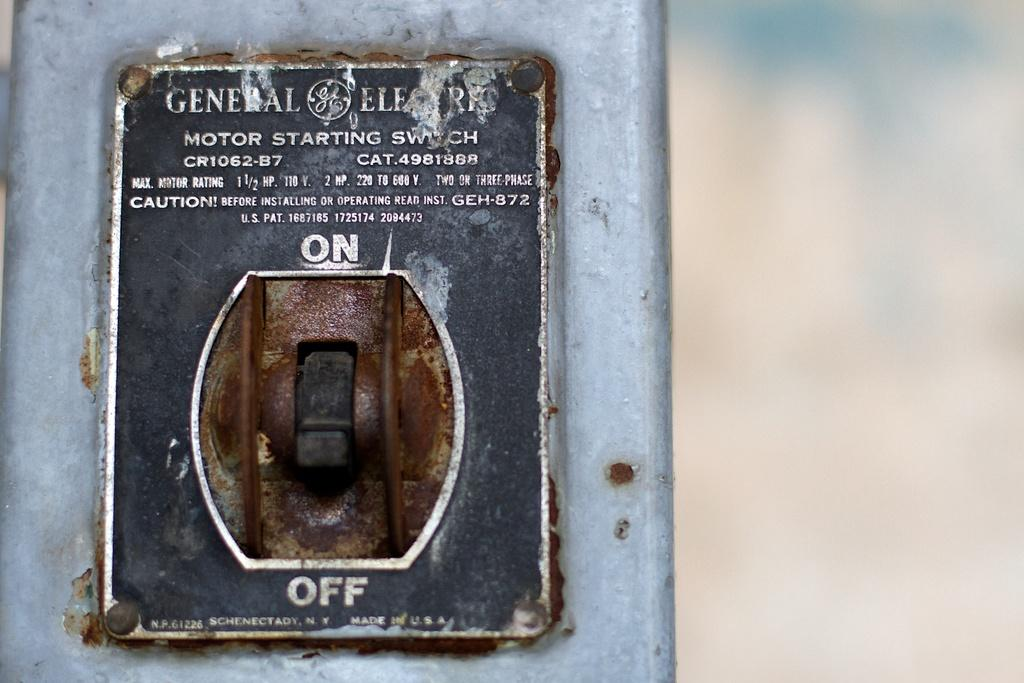<image>
Give a short and clear explanation of the subsequent image. a switch that has an off and also on switch 